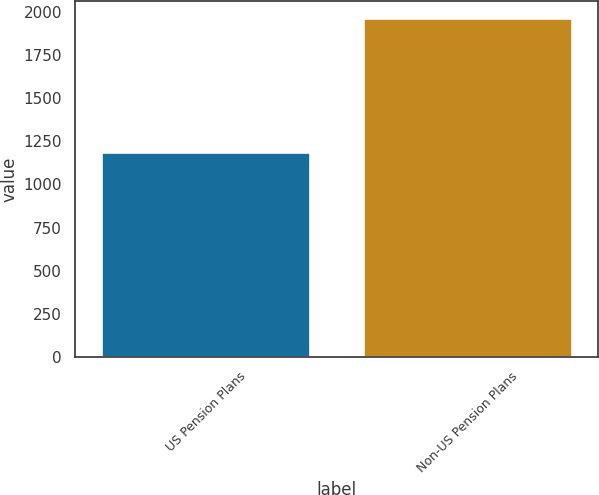Convert chart. <chart><loc_0><loc_0><loc_500><loc_500><bar_chart><fcel>US Pension Plans<fcel>Non-US Pension Plans<nl><fcel>1186<fcel>1963<nl></chart> 